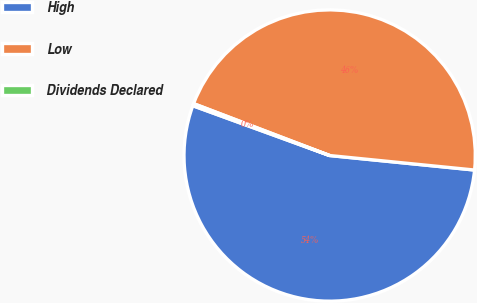Convert chart to OTSL. <chart><loc_0><loc_0><loc_500><loc_500><pie_chart><fcel>High<fcel>Low<fcel>Dividends Declared<nl><fcel>53.97%<fcel>45.79%<fcel>0.24%<nl></chart> 